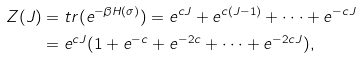<formula> <loc_0><loc_0><loc_500><loc_500>Z ( J ) & = t r ( e ^ { - \beta H ( \sigma ) } ) = e ^ { c J } + e ^ { c ( J - 1 ) } + \cdot \cdot \cdot + e ^ { - c J } \\ & = e ^ { c J } ( 1 + e ^ { - c } + e ^ { - 2 c } + \cdot \cdot \cdot + e ^ { - 2 c J } ) ,</formula> 